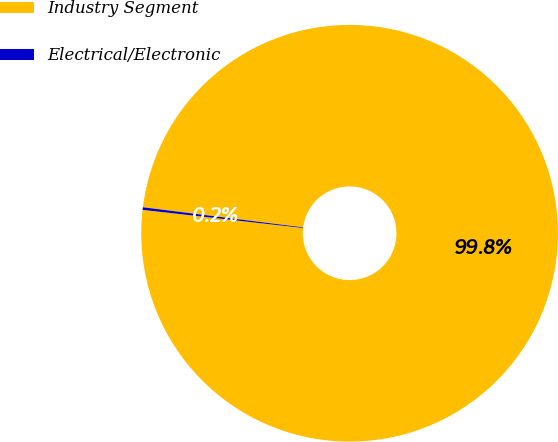<chart> <loc_0><loc_0><loc_500><loc_500><pie_chart><fcel>Industry Segment<fcel>Electrical/Electronic<nl><fcel>99.8%<fcel>0.2%<nl></chart> 